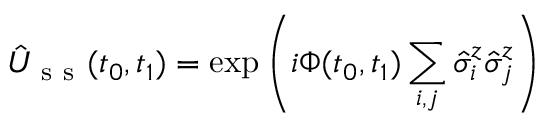Convert formula to latex. <formula><loc_0><loc_0><loc_500><loc_500>\hat { U } _ { s s } ( t _ { 0 } , t _ { 1 } ) = \exp \left ( { i \Phi ( t _ { 0 } , t _ { 1 } ) \sum _ { i , j } \hat { \sigma } _ { i } ^ { z } \hat { \sigma } _ { j } ^ { z } } \right )</formula> 